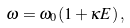Convert formula to latex. <formula><loc_0><loc_0><loc_500><loc_500>\omega = \omega _ { 0 } ( 1 + \kappa E ) \, ,</formula> 